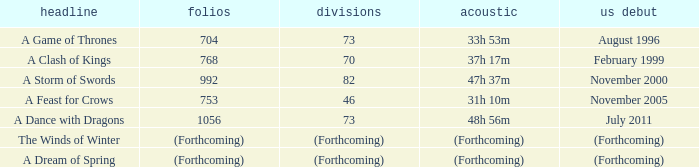Which US release has 704 pages? August 1996. 